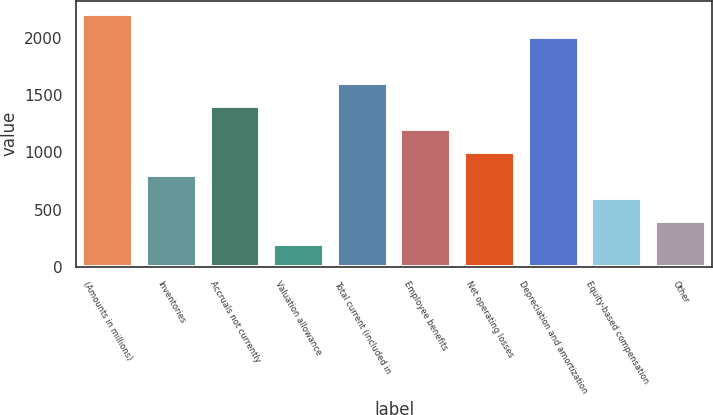Convert chart to OTSL. <chart><loc_0><loc_0><loc_500><loc_500><bar_chart><fcel>(Amounts in millions)<fcel>Inventories<fcel>Accruals not currently<fcel>Valuation allowance<fcel>Total current (included in<fcel>Employee benefits<fcel>Net operating losses<fcel>Depreciation and amortization<fcel>Equity-based compensation<fcel>Other<nl><fcel>2214.15<fcel>806.1<fcel>1409.55<fcel>202.65<fcel>1610.7<fcel>1208.4<fcel>1007.25<fcel>2013<fcel>604.95<fcel>403.8<nl></chart> 